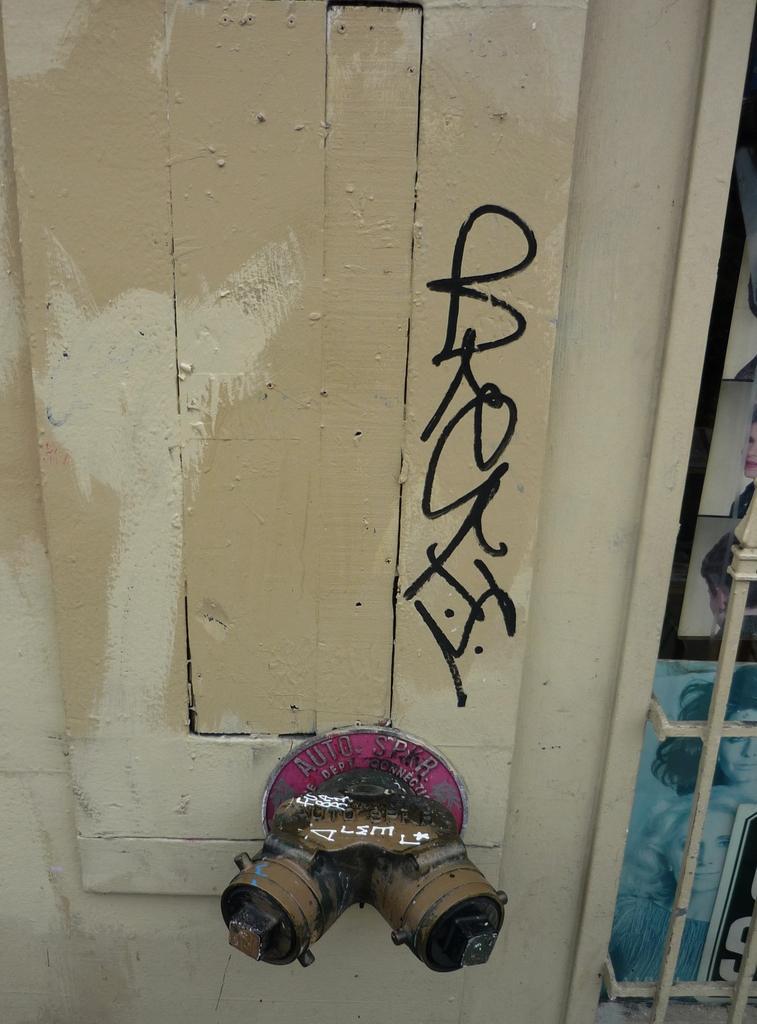How would you summarize this image in a sentence or two? In this picture we can see a wooden plank with text on it, metal object, photos and some objects. 